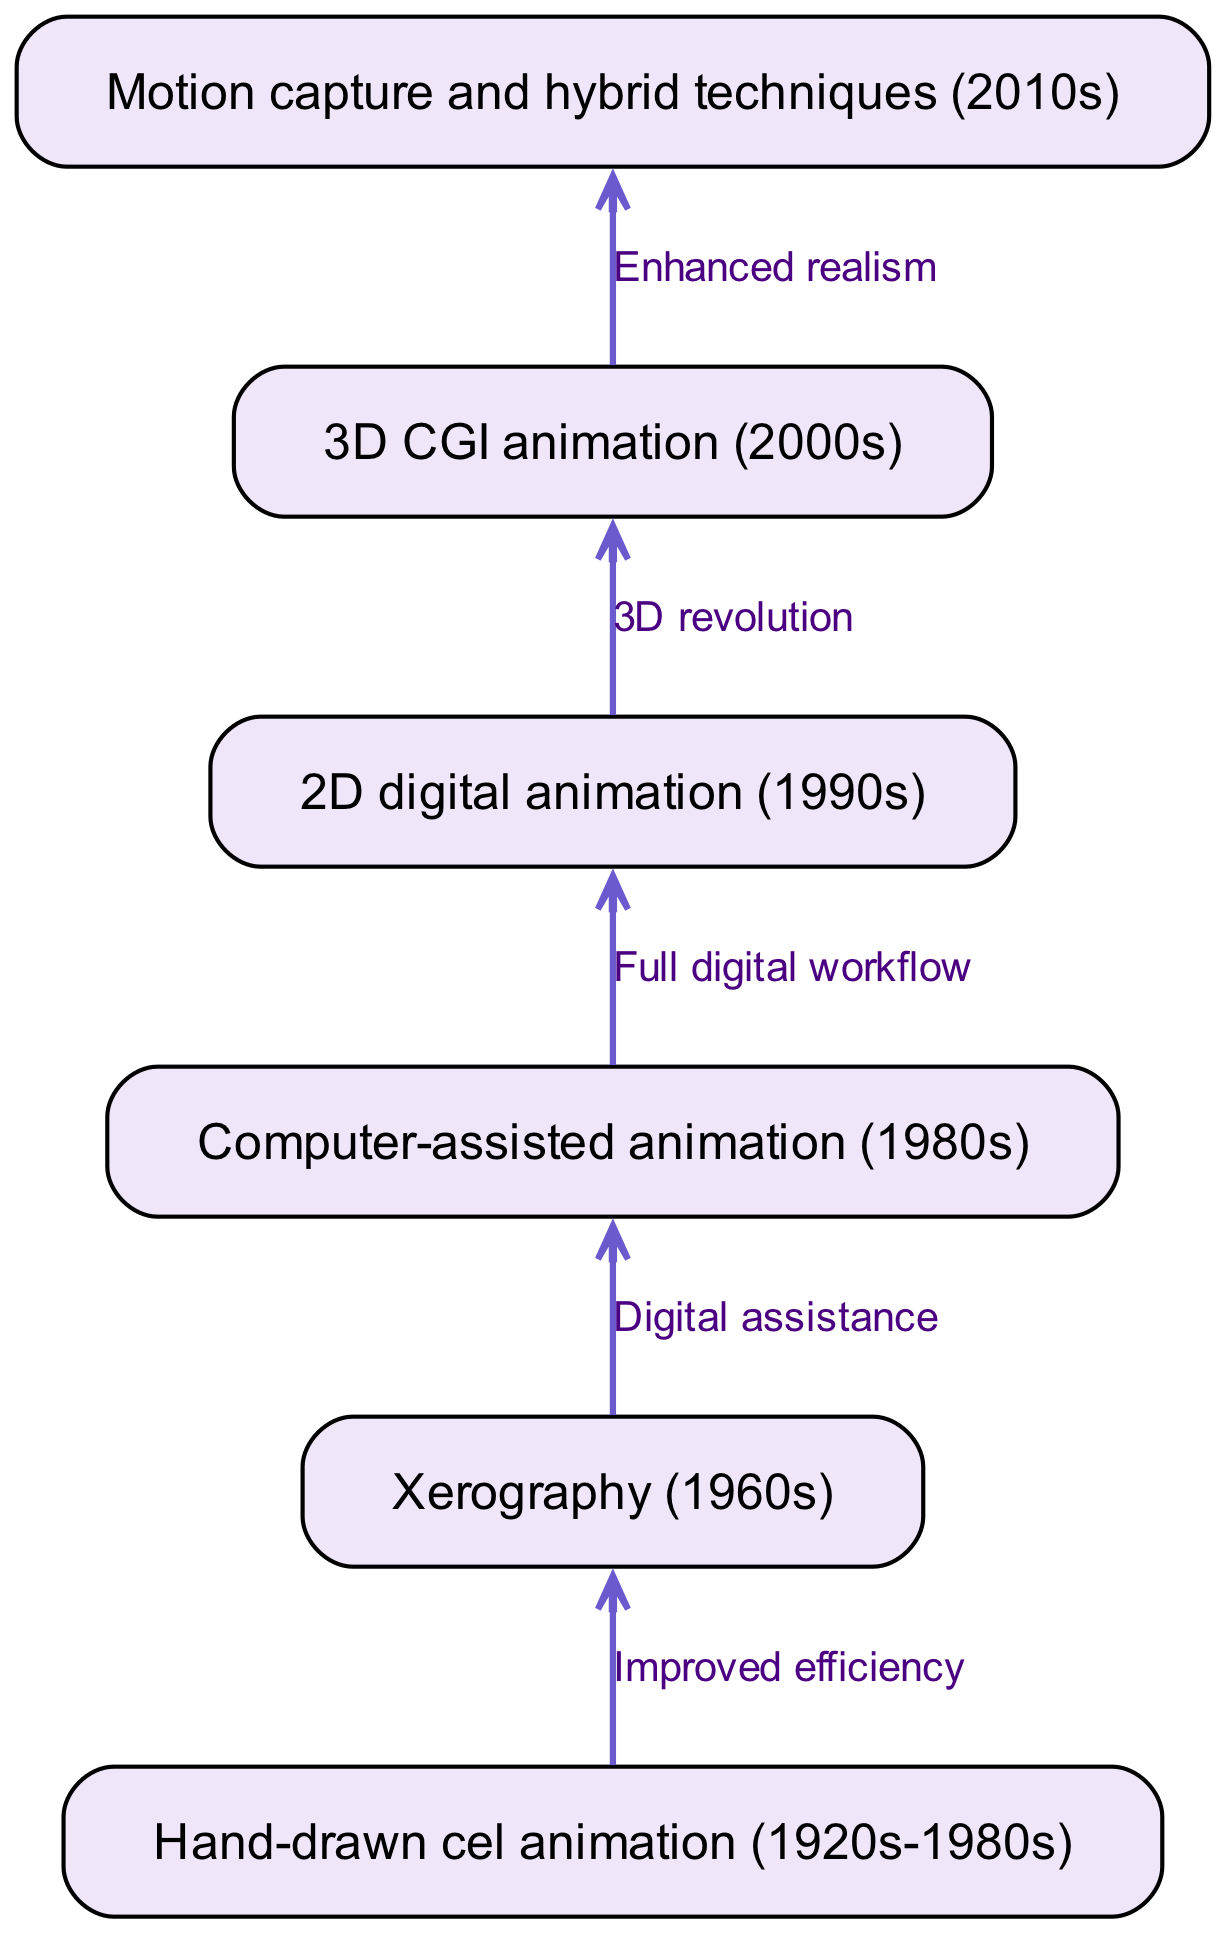What is the first technique in the flow chart? The first node in the diagram is labeled "Hand-drawn cel animation (1920s-1980s)," indicating that it is the starting point of the evolution of animation techniques.
Answer: Hand-drawn cel animation (1920s-1980s) How many nodes are present in the diagram? By counting the nodes listed in the data, there are six distinct animation techniques represented, each categorized under a unique label.
Answer: 6 Which technique comes after xerography? The diagram shows an edge leading from the node "Xerography (1960s)" to "Computer-assisted animation (1980s)," indicating this progression.
Answer: Computer-assisted animation (1980s) What is the relationship between hand-drawn cel animation and xerography? The edge connecting these two nodes is labeled "Improved efficiency," which describes the transition from hand-drawn cel animation to xerography as a means of enhancing the workflow in animation.
Answer: Improved efficiency What technique follows the 3D CGI animation? The edge flows from "3D CGI animation (2000s)" to "Motion capture and hybrid techniques (2010s)," indicating that this is the next stage in the evolution.
Answer: Motion capture and hybrid techniques (2010s) What common theme connects all techniques in the diagram? An overarching theme in the diagram is the progression towards increased efficiency and realism, which is observed as each technique builds upon its predecessor's innovations.
Answer: Progression towards increased efficiency and realism Which relationship indicates a digital transition? The relationship labeled "Digital assistance" connects xerography to computer-assisted animation, demonstrating a shift towards incorporating digital tools in animation techniques.
Answer: Digital assistance How many edges are there in the flow chart? By analyzing the edges provided in the data, there are five connections that indicate the relationships between the nodes.
Answer: 5 What does the edge from 2D digital animation to 3D CGI animation represent? This edge is labeled "3D revolution," indicating that the transition from 2D digital animation to 3D CGI animation marks a significant advancement in animation techniques.
Answer: 3D revolution 